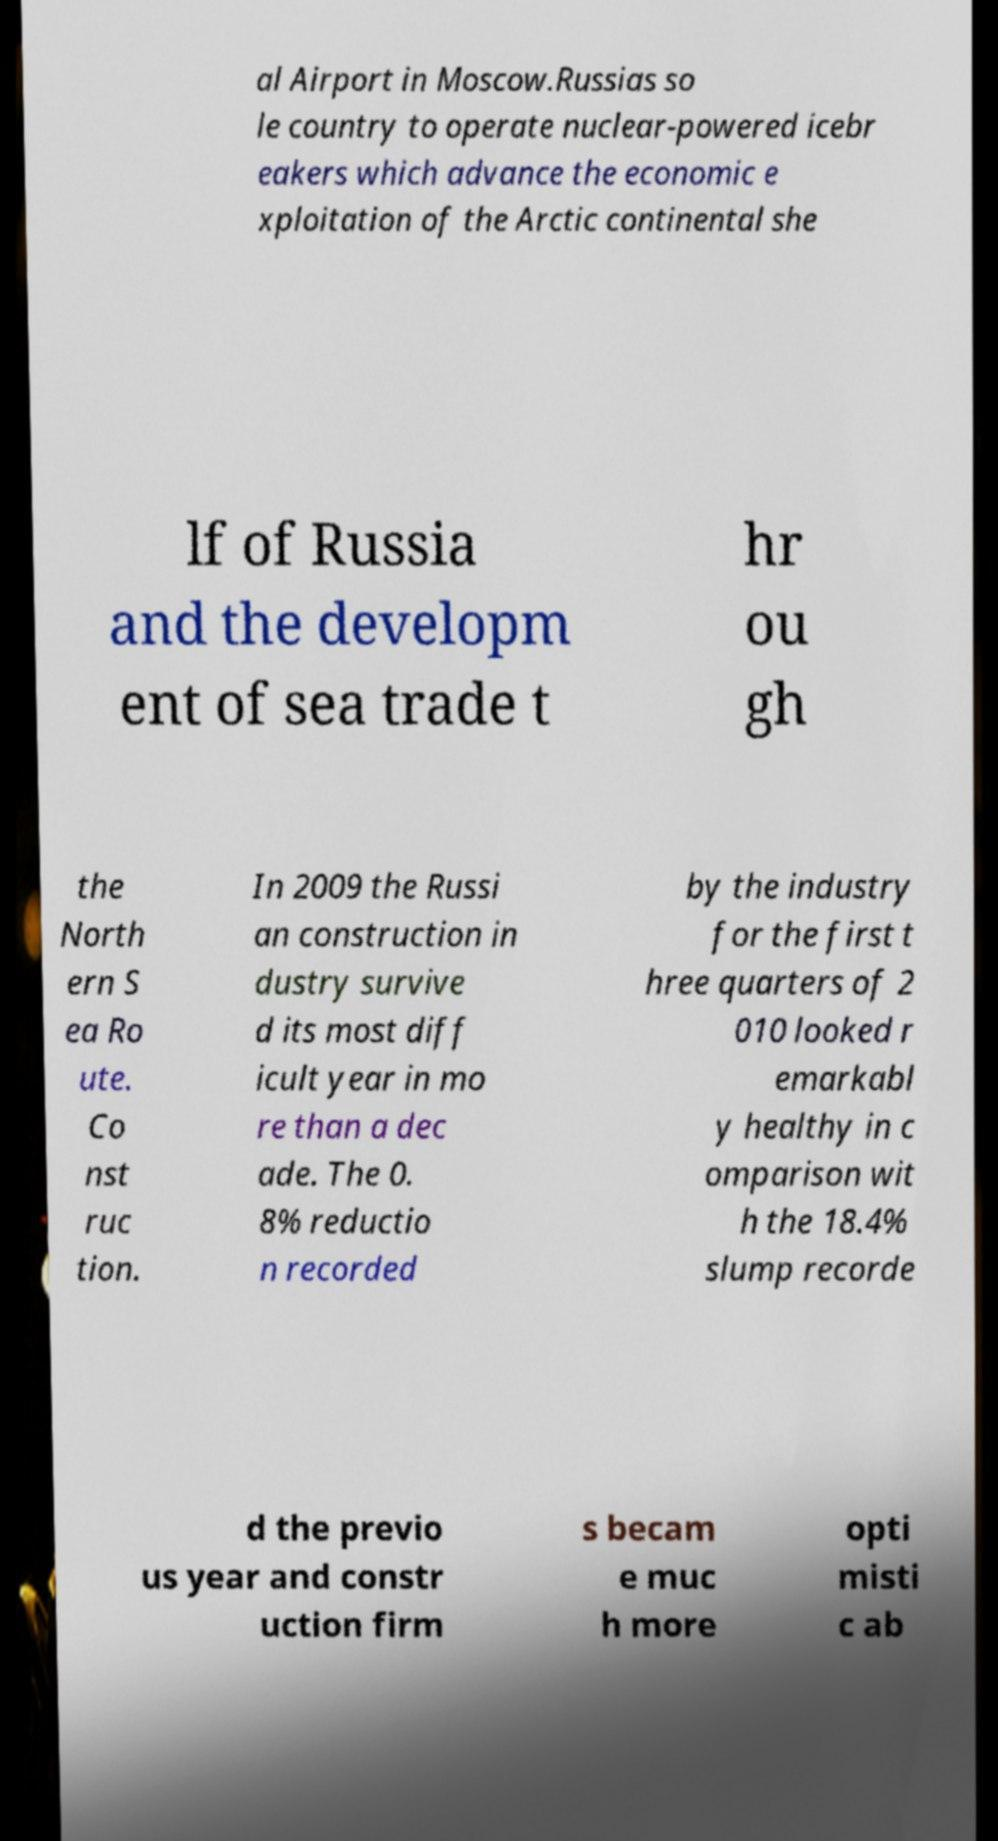Please read and relay the text visible in this image. What does it say? al Airport in Moscow.Russias so le country to operate nuclear-powered icebr eakers which advance the economic e xploitation of the Arctic continental she lf of Russia and the developm ent of sea trade t hr ou gh the North ern S ea Ro ute. Co nst ruc tion. In 2009 the Russi an construction in dustry survive d its most diff icult year in mo re than a dec ade. The 0. 8% reductio n recorded by the industry for the first t hree quarters of 2 010 looked r emarkabl y healthy in c omparison wit h the 18.4% slump recorde d the previo us year and constr uction firm s becam e muc h more opti misti c ab 